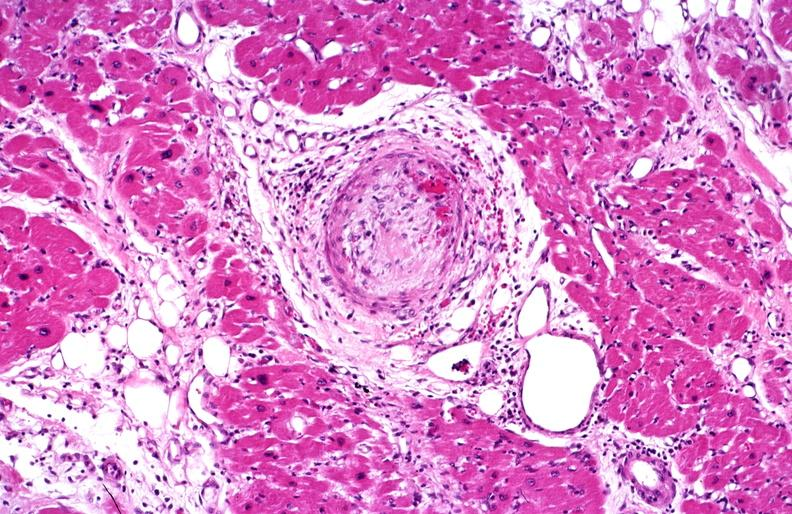s quite good liver present?
Answer the question using a single word or phrase. No 